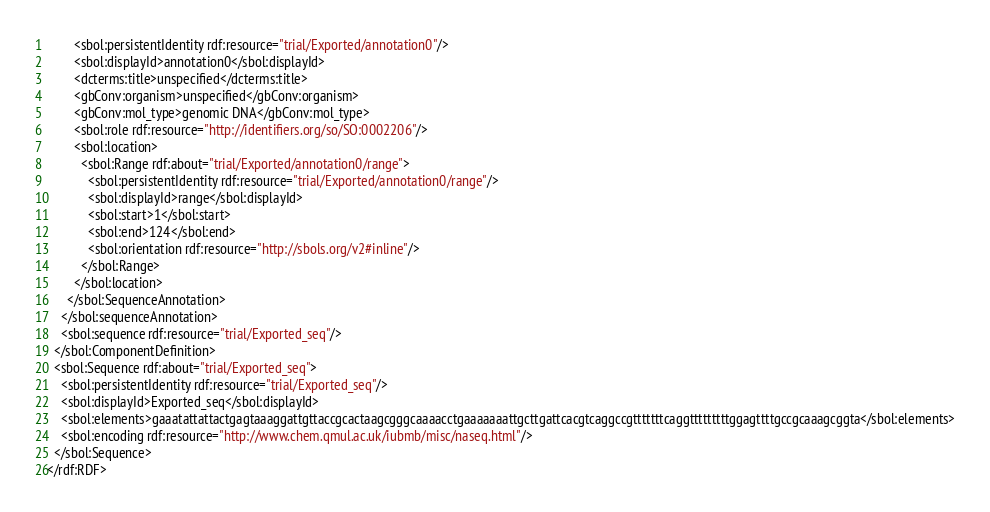Convert code to text. <code><loc_0><loc_0><loc_500><loc_500><_XML_>        <sbol:persistentIdentity rdf:resource="trial/Exported/annotation0"/>
        <sbol:displayId>annotation0</sbol:displayId>
        <dcterms:title>unspecified</dcterms:title>
        <gbConv:organism>unspecified</gbConv:organism>
        <gbConv:mol_type>genomic DNA</gbConv:mol_type>
        <sbol:role rdf:resource="http://identifiers.org/so/SO:0002206"/>
        <sbol:location>
          <sbol:Range rdf:about="trial/Exported/annotation0/range">
            <sbol:persistentIdentity rdf:resource="trial/Exported/annotation0/range"/>
            <sbol:displayId>range</sbol:displayId>
            <sbol:start>1</sbol:start>
            <sbol:end>124</sbol:end>
            <sbol:orientation rdf:resource="http://sbols.org/v2#inline"/>
          </sbol:Range>
        </sbol:location>
      </sbol:SequenceAnnotation>
    </sbol:sequenceAnnotation>
    <sbol:sequence rdf:resource="trial/Exported_seq"/>
  </sbol:ComponentDefinition>
  <sbol:Sequence rdf:about="trial/Exported_seq">
    <sbol:persistentIdentity rdf:resource="trial/Exported_seq"/>
    <sbol:displayId>Exported_seq</sbol:displayId>
    <sbol:elements>gaaatattattactgagtaaaggattgttaccgcactaagcgggcaaaacctgaaaaaaattgcttgattcacgtcaggccgtttttttcaggtttttttttggagttttgccgcaaagcggta</sbol:elements>
    <sbol:encoding rdf:resource="http://www.chem.qmul.ac.uk/iubmb/misc/naseq.html"/>
  </sbol:Sequence>
</rdf:RDF>
</code> 